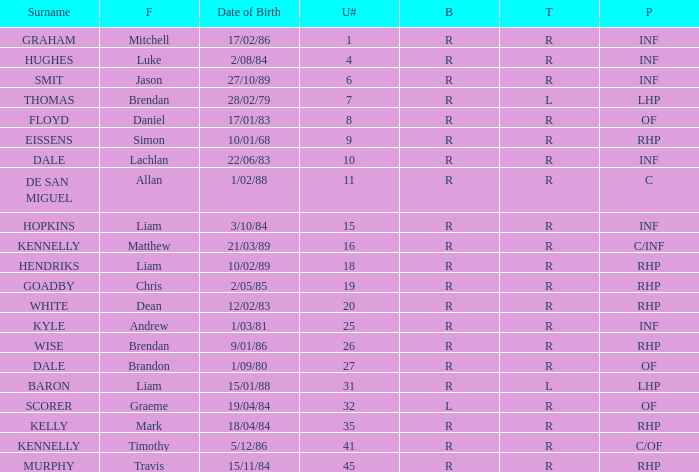Which player has a last name of baron? R. 